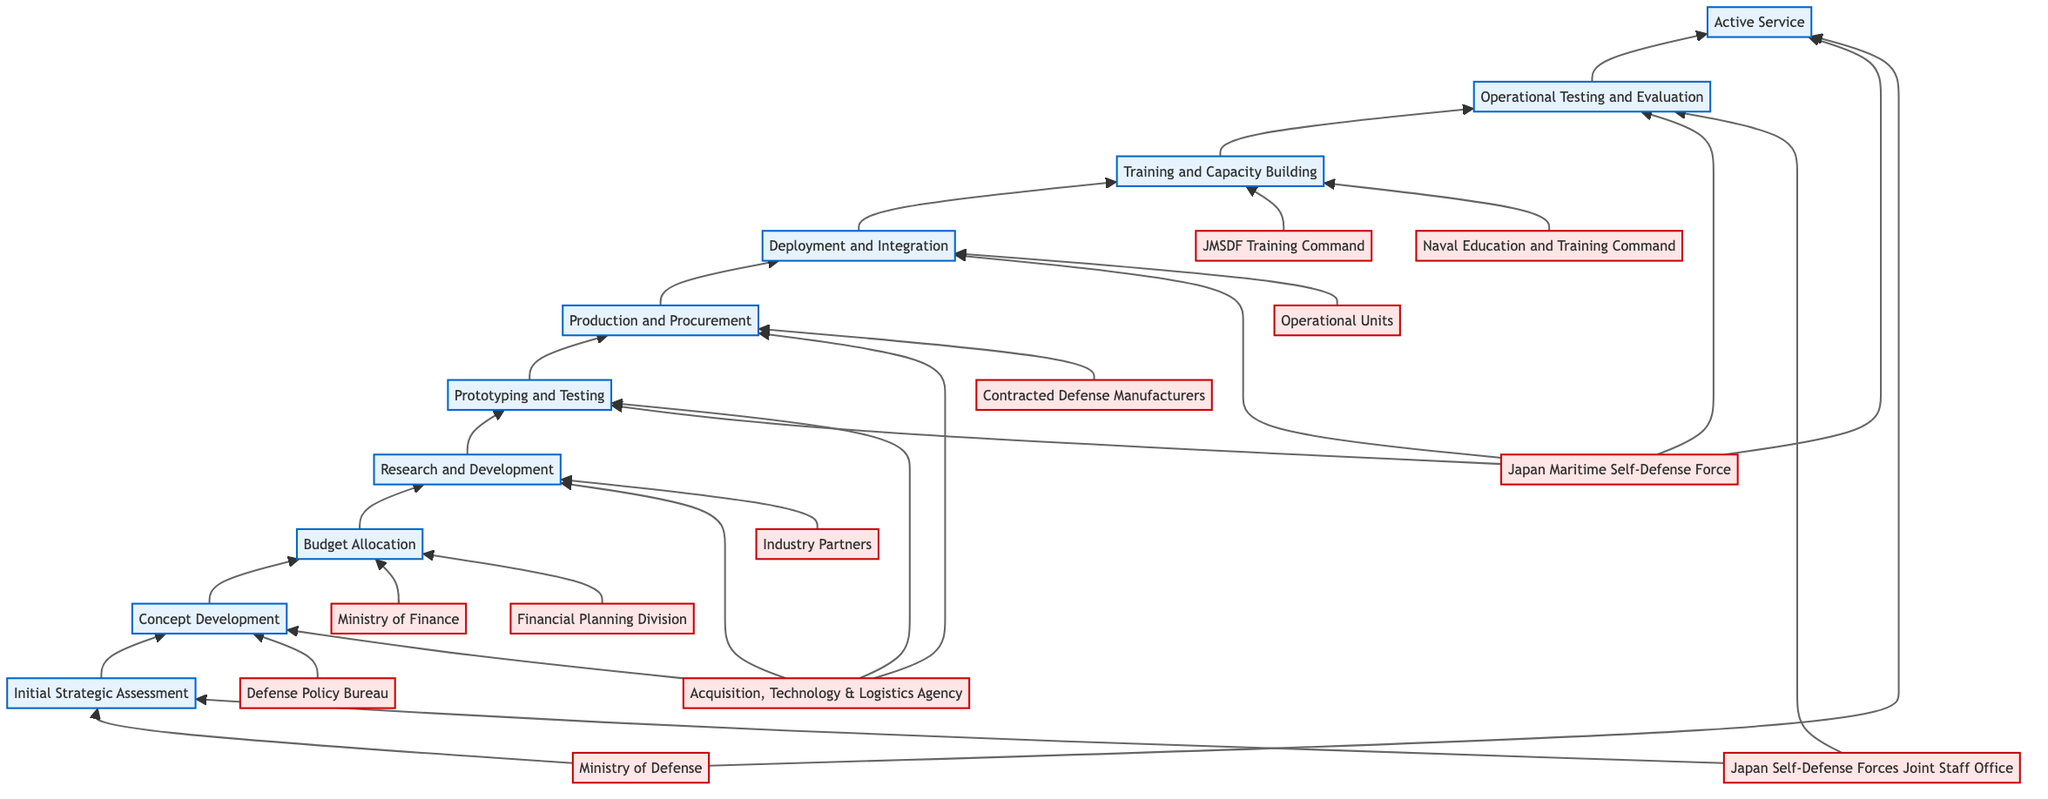What is the first step in the timeline? The timeline begins with the "Initial Strategic Assessment," which is the first node in the diagram.
Answer: Initial Strategic Assessment Which entities are involved in the "Budget Allocation" step? The "Budget Allocation" step lists two entities: the "Ministry of Finance" and the "Financial Planning Division." This information can be found by looking directly above the corresponding step node.
Answer: Ministry of Finance, Financial Planning Division How many total steps are there in the timeline? By counting the nodes from the diagram, there are ten steps total in the timeline.
Answer: 10 What is the last step before "Active Service"? The step immediately prior to "Active Service" is "Operational Testing and Evaluation," which is linked directly beneath it in the flow.
Answer: Operational Testing and Evaluation Which entity is involved in both "Prototyping and Testing" and "Deployment and Integration"? The entity "JMSDF" (Japan Maritime Self-Defense Force) is involved in both the "Prototyping and Testing" and "Deployment and Integration" steps, as indicated by the connections from both nodes.
Answer: JMSDF What is the relationship between "Research and Development" and "Prototyping and Testing"? "Research and Development" leads into "Prototyping and Testing," indicating that R&D is a prerequisite for this step, as shown by the upward arrow connecting them in the flowchart.
Answer: Leads into Which step do the "Industry Partners" contribute to? "Industry Partners" are involved in the "Research and Development" step. This is evident from their connection to node four in the diagram.
Answer: Research and Development What is the main focus of the "Training and Capacity Building" step? The primary focus of "Training and Capacity Building" is on training personnel and building capacity to operate and maintain new systems, as described directly in the step node.
Answer: Training personnel and building capacity What is the final step in the process described by the diagram? The final step in the timeline is "Active Service," which is the last node at the top of the flowchart, representing the culmination of all previous steps.
Answer: Active Service 